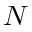<formula> <loc_0><loc_0><loc_500><loc_500>N</formula> 